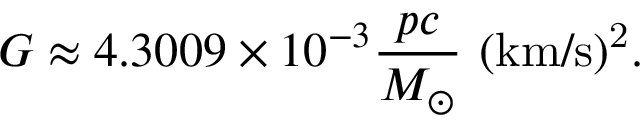Convert formula to latex. <formula><loc_0><loc_0><loc_500><loc_500>G \approx 4 . 3 0 0 9 \times 1 0 ^ { - 3 { \frac { p c } { M _ { \odot } } } { \ ( k m / s ) ^ { 2 } } .</formula> 